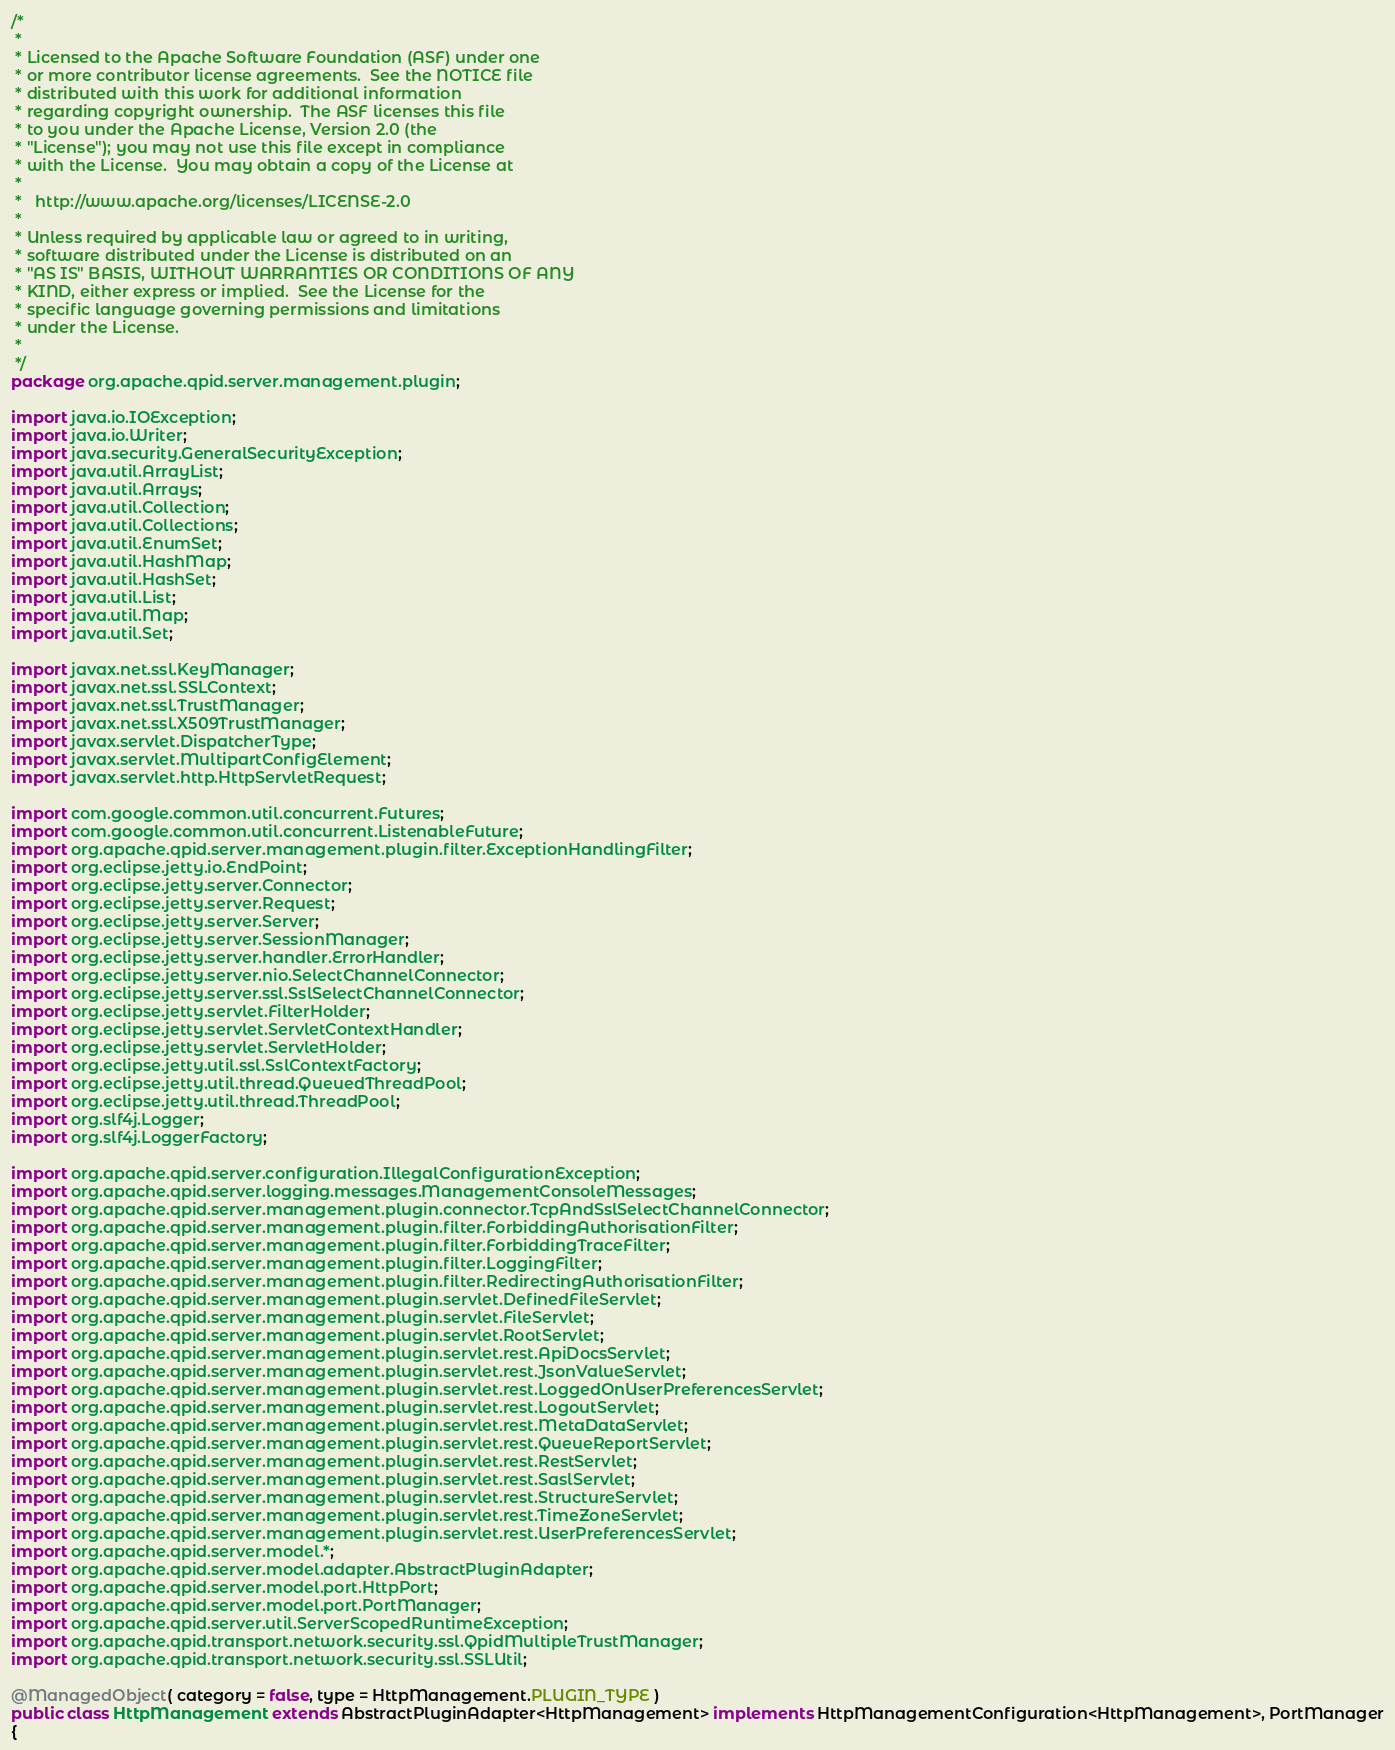Convert code to text. <code><loc_0><loc_0><loc_500><loc_500><_Java_>/*
 *
 * Licensed to the Apache Software Foundation (ASF) under one
 * or more contributor license agreements.  See the NOTICE file
 * distributed with this work for additional information
 * regarding copyright ownership.  The ASF licenses this file
 * to you under the Apache License, Version 2.0 (the
 * "License"); you may not use this file except in compliance
 * with the License.  You may obtain a copy of the License at
 *
 *   http://www.apache.org/licenses/LICENSE-2.0
 *
 * Unless required by applicable law or agreed to in writing,
 * software distributed under the License is distributed on an
 * "AS IS" BASIS, WITHOUT WARRANTIES OR CONDITIONS OF ANY
 * KIND, either express or implied.  See the License for the
 * specific language governing permissions and limitations
 * under the License.
 *
 */
package org.apache.qpid.server.management.plugin;

import java.io.IOException;
import java.io.Writer;
import java.security.GeneralSecurityException;
import java.util.ArrayList;
import java.util.Arrays;
import java.util.Collection;
import java.util.Collections;
import java.util.EnumSet;
import java.util.HashMap;
import java.util.HashSet;
import java.util.List;
import java.util.Map;
import java.util.Set;

import javax.net.ssl.KeyManager;
import javax.net.ssl.SSLContext;
import javax.net.ssl.TrustManager;
import javax.net.ssl.X509TrustManager;
import javax.servlet.DispatcherType;
import javax.servlet.MultipartConfigElement;
import javax.servlet.http.HttpServletRequest;

import com.google.common.util.concurrent.Futures;
import com.google.common.util.concurrent.ListenableFuture;
import org.apache.qpid.server.management.plugin.filter.ExceptionHandlingFilter;
import org.eclipse.jetty.io.EndPoint;
import org.eclipse.jetty.server.Connector;
import org.eclipse.jetty.server.Request;
import org.eclipse.jetty.server.Server;
import org.eclipse.jetty.server.SessionManager;
import org.eclipse.jetty.server.handler.ErrorHandler;
import org.eclipse.jetty.server.nio.SelectChannelConnector;
import org.eclipse.jetty.server.ssl.SslSelectChannelConnector;
import org.eclipse.jetty.servlet.FilterHolder;
import org.eclipse.jetty.servlet.ServletContextHandler;
import org.eclipse.jetty.servlet.ServletHolder;
import org.eclipse.jetty.util.ssl.SslContextFactory;
import org.eclipse.jetty.util.thread.QueuedThreadPool;
import org.eclipse.jetty.util.thread.ThreadPool;
import org.slf4j.Logger;
import org.slf4j.LoggerFactory;

import org.apache.qpid.server.configuration.IllegalConfigurationException;
import org.apache.qpid.server.logging.messages.ManagementConsoleMessages;
import org.apache.qpid.server.management.plugin.connector.TcpAndSslSelectChannelConnector;
import org.apache.qpid.server.management.plugin.filter.ForbiddingAuthorisationFilter;
import org.apache.qpid.server.management.plugin.filter.ForbiddingTraceFilter;
import org.apache.qpid.server.management.plugin.filter.LoggingFilter;
import org.apache.qpid.server.management.plugin.filter.RedirectingAuthorisationFilter;
import org.apache.qpid.server.management.plugin.servlet.DefinedFileServlet;
import org.apache.qpid.server.management.plugin.servlet.FileServlet;
import org.apache.qpid.server.management.plugin.servlet.RootServlet;
import org.apache.qpid.server.management.plugin.servlet.rest.ApiDocsServlet;
import org.apache.qpid.server.management.plugin.servlet.rest.JsonValueServlet;
import org.apache.qpid.server.management.plugin.servlet.rest.LoggedOnUserPreferencesServlet;
import org.apache.qpid.server.management.plugin.servlet.rest.LogoutServlet;
import org.apache.qpid.server.management.plugin.servlet.rest.MetaDataServlet;
import org.apache.qpid.server.management.plugin.servlet.rest.QueueReportServlet;
import org.apache.qpid.server.management.plugin.servlet.rest.RestServlet;
import org.apache.qpid.server.management.plugin.servlet.rest.SaslServlet;
import org.apache.qpid.server.management.plugin.servlet.rest.StructureServlet;
import org.apache.qpid.server.management.plugin.servlet.rest.TimeZoneServlet;
import org.apache.qpid.server.management.plugin.servlet.rest.UserPreferencesServlet;
import org.apache.qpid.server.model.*;
import org.apache.qpid.server.model.adapter.AbstractPluginAdapter;
import org.apache.qpid.server.model.port.HttpPort;
import org.apache.qpid.server.model.port.PortManager;
import org.apache.qpid.server.util.ServerScopedRuntimeException;
import org.apache.qpid.transport.network.security.ssl.QpidMultipleTrustManager;
import org.apache.qpid.transport.network.security.ssl.SSLUtil;

@ManagedObject( category = false, type = HttpManagement.PLUGIN_TYPE )
public class HttpManagement extends AbstractPluginAdapter<HttpManagement> implements HttpManagementConfiguration<HttpManagement>, PortManager
{</code> 